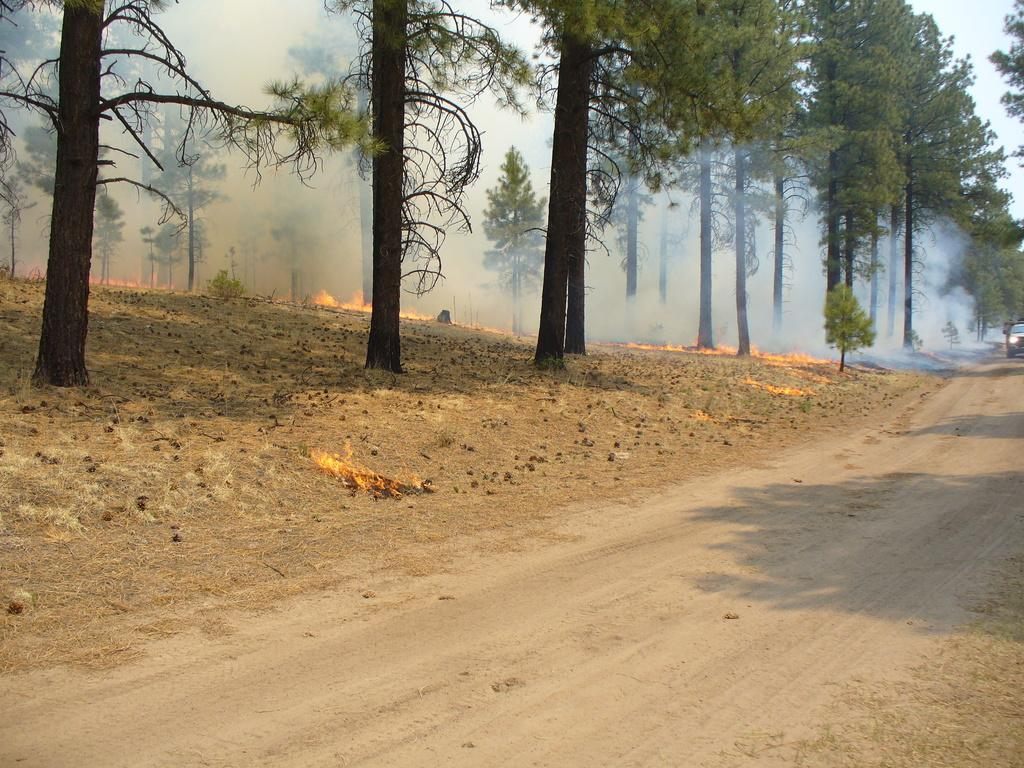What is on the road in the image? There is a vehicle on the road in the image. What type of natural elements can be seen in the image? There are trees in the image. What is happening in the image that involves heat and combustion? There is fire visible in the image. What is the result of the fire in the image? There is smoke in the image as a result of the fire. Can you describe the harmony between the seashore and the vehicle in the image? There is no seashore present in the image, so it is not possible to describe any harmony between it and the vehicle. 